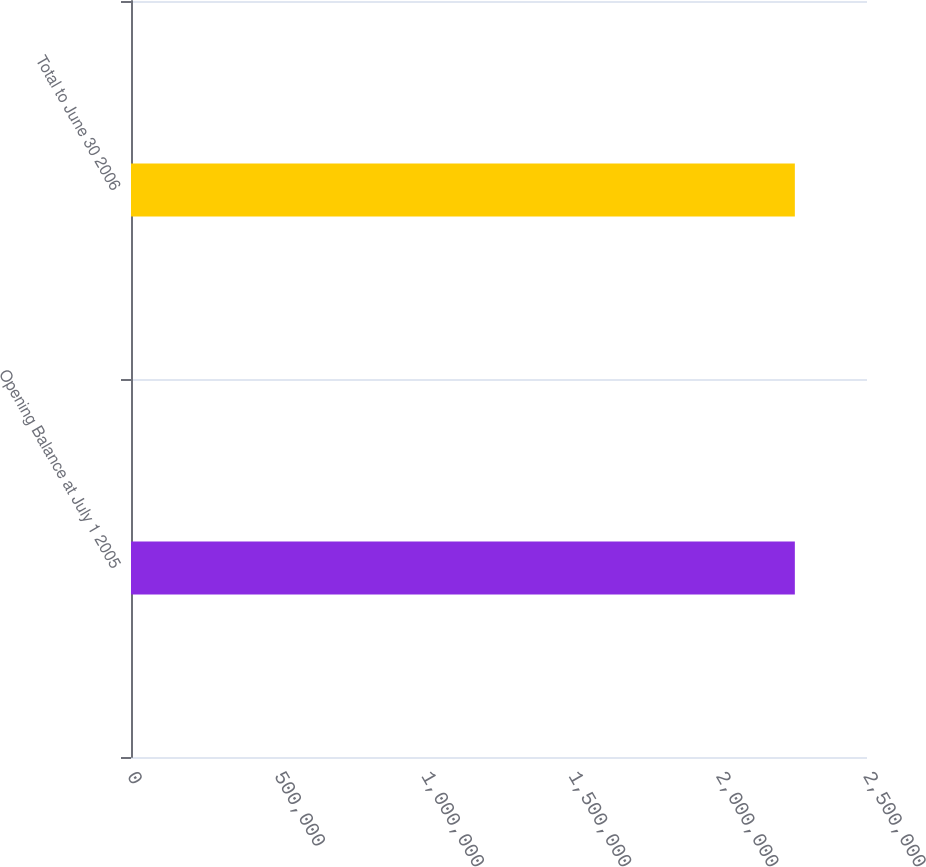Convert chart. <chart><loc_0><loc_0><loc_500><loc_500><bar_chart><fcel>Opening Balance at July 1 2005<fcel>Total to June 30 2006<nl><fcel>2.25492e+06<fcel>2.25492e+06<nl></chart> 